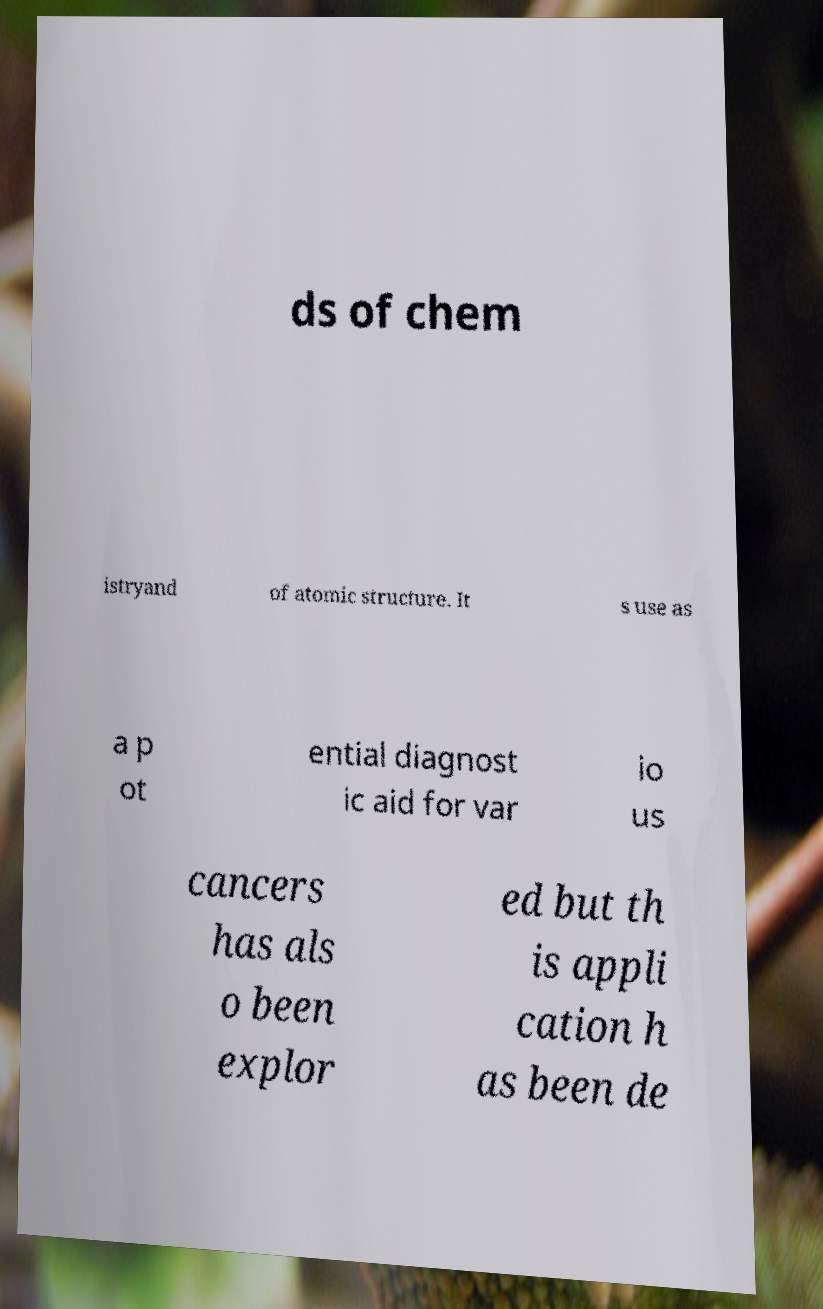For documentation purposes, I need the text within this image transcribed. Could you provide that? ds of chem istryand of atomic structure. It s use as a p ot ential diagnost ic aid for var io us cancers has als o been explor ed but th is appli cation h as been de 